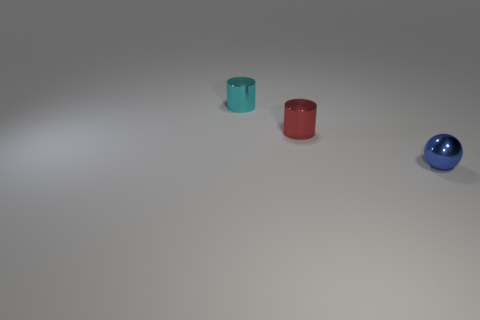Add 1 tiny metallic objects. How many objects exist? 4 Subtract 1 balls. How many balls are left? 0 Add 2 blue balls. How many blue balls exist? 3 Subtract 0 brown cylinders. How many objects are left? 3 Subtract all balls. How many objects are left? 2 Subtract all yellow cylinders. Subtract all red spheres. How many cylinders are left? 2 Subtract all gray spheres. How many cyan cylinders are left? 1 Subtract all red blocks. Subtract all small red objects. How many objects are left? 2 Add 3 tiny red shiny cylinders. How many tiny red shiny cylinders are left? 4 